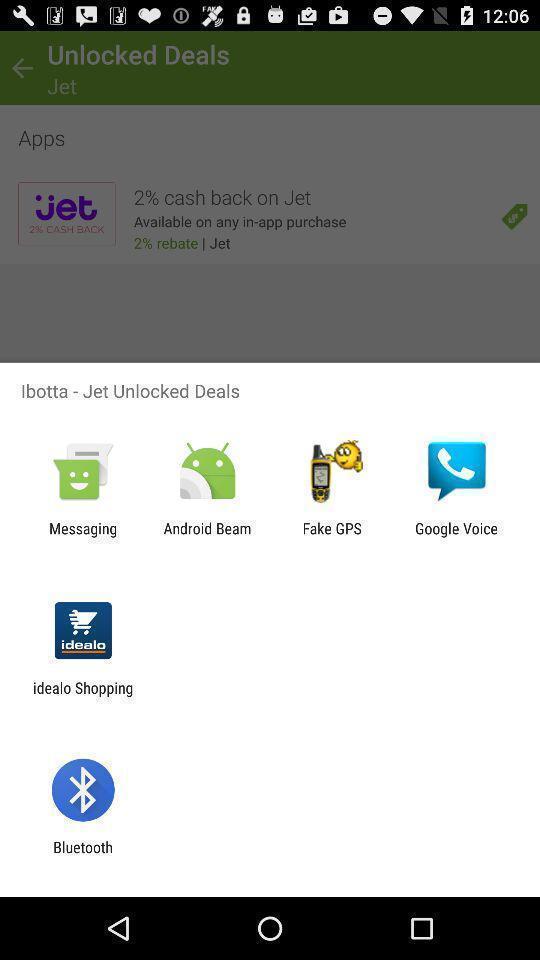Provide a detailed account of this screenshot. Pop-up for unlocked deals sharing with other selective app. 